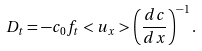<formula> <loc_0><loc_0><loc_500><loc_500>D _ { t } = - c _ { 0 } f _ { t } < u _ { x } > \left ( \frac { d c } { d x } \right ) ^ { - 1 } .</formula> 